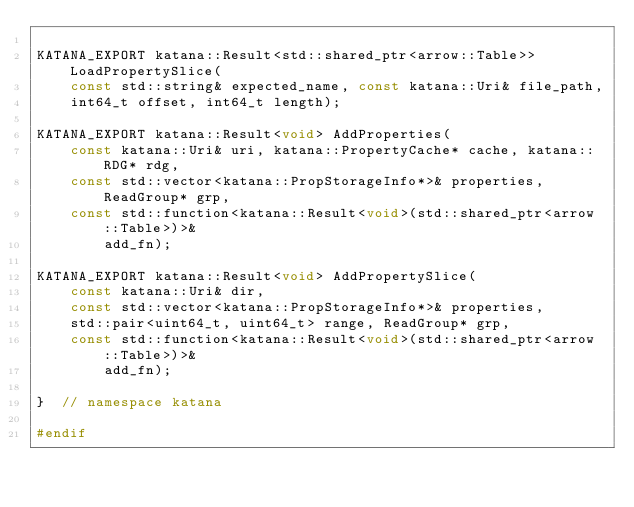Convert code to text. <code><loc_0><loc_0><loc_500><loc_500><_C_>
KATANA_EXPORT katana::Result<std::shared_ptr<arrow::Table>> LoadPropertySlice(
    const std::string& expected_name, const katana::Uri& file_path,
    int64_t offset, int64_t length);

KATANA_EXPORT katana::Result<void> AddProperties(
    const katana::Uri& uri, katana::PropertyCache* cache, katana::RDG* rdg,
    const std::vector<katana::PropStorageInfo*>& properties, ReadGroup* grp,
    const std::function<katana::Result<void>(std::shared_ptr<arrow::Table>)>&
        add_fn);

KATANA_EXPORT katana::Result<void> AddPropertySlice(
    const katana::Uri& dir,
    const std::vector<katana::PropStorageInfo*>& properties,
    std::pair<uint64_t, uint64_t> range, ReadGroup* grp,
    const std::function<katana::Result<void>(std::shared_ptr<arrow::Table>)>&
        add_fn);

}  // namespace katana

#endif
</code> 